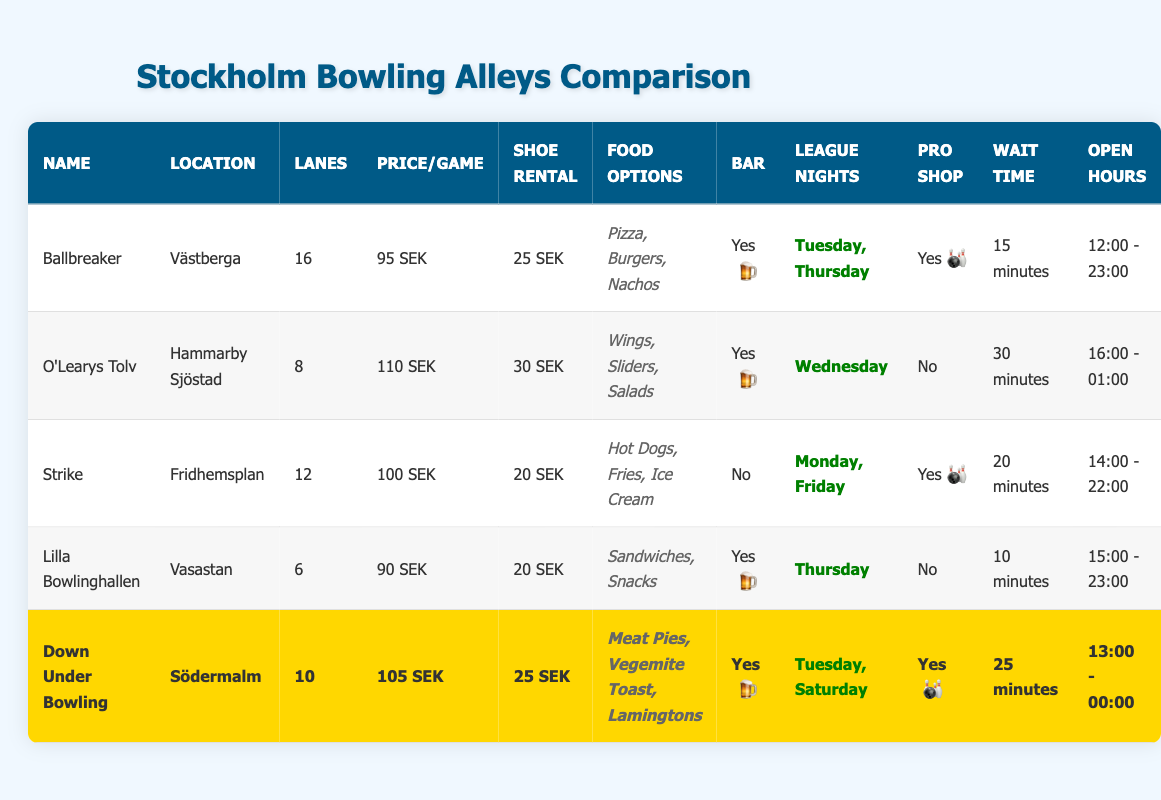What is the location of the bowling alley named "Strike"? The table lists "Strike" under the column for names, and the corresponding location in the same row is "Fridhemsplan."
Answer: Fridhemsplan How many lanes does "Lilla Bowlinghallen" have compared to "Ballbreaker"? "Lilla Bowlinghallen" has 6 lanes, while "Ballbreaker" has 16 lanes. The difference is 16 - 6 = 10 lanes, so "Ballbreaker" has 10 more lanes than "Lilla Bowlinghallen."
Answer: 10 more lanes Does "Down Under Bowling" have a pro shop? The "Pro Shop" column for "Down Under Bowling" shows "Yes," indicating that it does have a pro shop.
Answer: Yes Which bowling alley has the longest average wait time? "O'Learys Tolv" has an average wait time of 30 minutes, which is the highest compared to the other bowling alleys listed in the table.
Answer: O'Learys Tolv What are the food options available at "Ballbreaker"? The table lists the food options for "Ballbreaker" as Pizza, Burgers, and Nachos in the corresponding row.
Answer: Pizza, Burgers, Nachos Which bowling alley is australian themed and how many lanes does it have? The table highlights "Down Under Bowling" as the only bowling alley with an "australian themed" designation. This alley has 10 lanes, as seen in its corresponding row.
Answer: Down Under Bowling, 10 lanes What is the average price per game among all the bowling alleys? To find the average price, we add the prices per game: 95 + 110 + 100 + 90 + 105 = 500. There are 5 bowling alleys, so we divide 500 by 5 which results in an average of 100 SEK.
Answer: 100 SEK Is there a bar at "Lilla Bowlinghallen"? In the table, the "Bar" column indicates "Yes" for "Lilla Bowlinghallen," meaning it does have a bar.
Answer: Yes How many total lanes are there across all bowling alleys? We sum the number of lanes from all the bowling alleys: 16 (Ballbreaker) + 8 (O'Learys Tolv) + 12 (Strike) + 6 (Lilla Bowlinghallen) + 10 (Down Under Bowling) = 52 lanes in total.
Answer: 52 lanes 